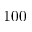Convert formula to latex. <formula><loc_0><loc_0><loc_500><loc_500>1 0 0</formula> 